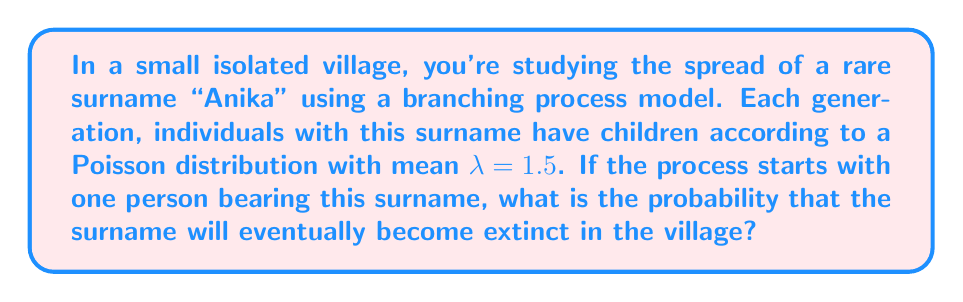Can you answer this question? To solve this problem, we'll use the theory of branching processes:

1) In a branching process, the probability of extinction, $q$, satisfies the equation:
   $q = G(q)$
   where $G(s)$ is the probability generating function (PGF) of the offspring distribution.

2) For a Poisson distribution with mean $\lambda$, the PGF is:
   $G(s) = e^{\lambda(s-1)}$

3) Substituting our $\lambda = 1.5$, we get:
   $q = e^{1.5(q-1)}$

4) This equation can't be solved algebraically, but we know that:
   - If $\lambda \leq 1$, $q = 1$ (certain extinction)
   - If $\lambda > 1$, $q$ is the smaller root of the equation $q = G(q)$ in $[0,1]$

5) Since $\lambda = 1.5 > 1$, we need to find the smaller root of:
   $q = e^{1.5(q-1)}$

6) We can solve this numerically. Using Newton's method or a similar approach, we find:
   $q \approx 0.4173$

Therefore, the probability of eventual extinction is approximately 0.4173 or 41.73%.
Answer: $0.4173$ 